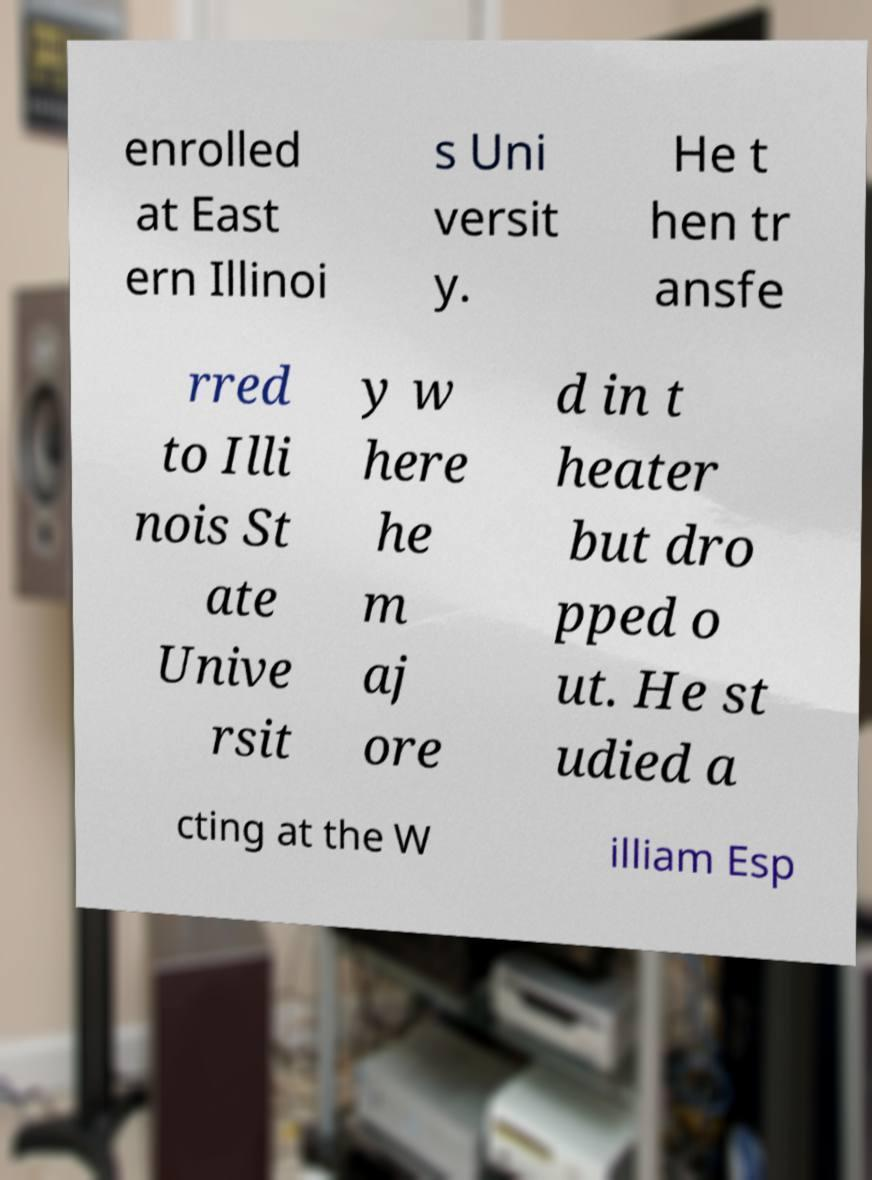What messages or text are displayed in this image? I need them in a readable, typed format. enrolled at East ern Illinoi s Uni versit y. He t hen tr ansfe rred to Illi nois St ate Unive rsit y w here he m aj ore d in t heater but dro pped o ut. He st udied a cting at the W illiam Esp 